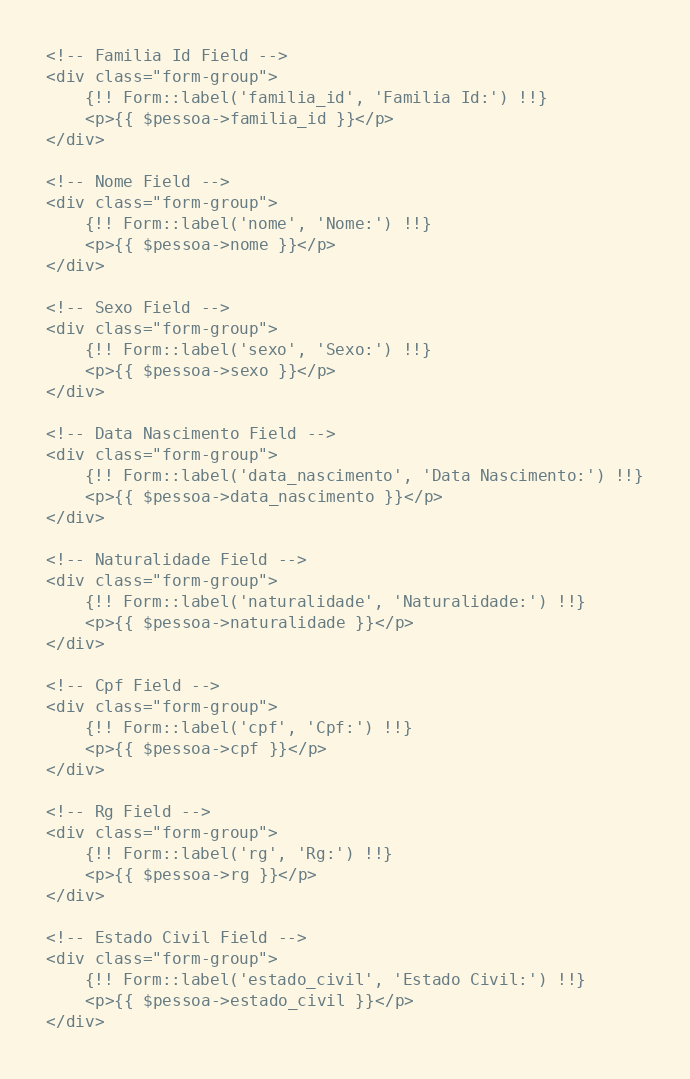<code> <loc_0><loc_0><loc_500><loc_500><_PHP_><!-- Familia Id Field -->
<div class="form-group">
    {!! Form::label('familia_id', 'Familia Id:') !!}
    <p>{{ $pessoa->familia_id }}</p>
</div>

<!-- Nome Field -->
<div class="form-group">
    {!! Form::label('nome', 'Nome:') !!}
    <p>{{ $pessoa->nome }}</p>
</div>

<!-- Sexo Field -->
<div class="form-group">
    {!! Form::label('sexo', 'Sexo:') !!}
    <p>{{ $pessoa->sexo }}</p>
</div>

<!-- Data Nascimento Field -->
<div class="form-group">
    {!! Form::label('data_nascimento', 'Data Nascimento:') !!}
    <p>{{ $pessoa->data_nascimento }}</p>
</div>

<!-- Naturalidade Field -->
<div class="form-group">
    {!! Form::label('naturalidade', 'Naturalidade:') !!}
    <p>{{ $pessoa->naturalidade }}</p>
</div>

<!-- Cpf Field -->
<div class="form-group">
    {!! Form::label('cpf', 'Cpf:') !!}
    <p>{{ $pessoa->cpf }}</p>
</div>

<!-- Rg Field -->
<div class="form-group">
    {!! Form::label('rg', 'Rg:') !!}
    <p>{{ $pessoa->rg }}</p>
</div>

<!-- Estado Civil Field -->
<div class="form-group">
    {!! Form::label('estado_civil', 'Estado Civil:') !!}
    <p>{{ $pessoa->estado_civil }}</p>
</div>

</code> 